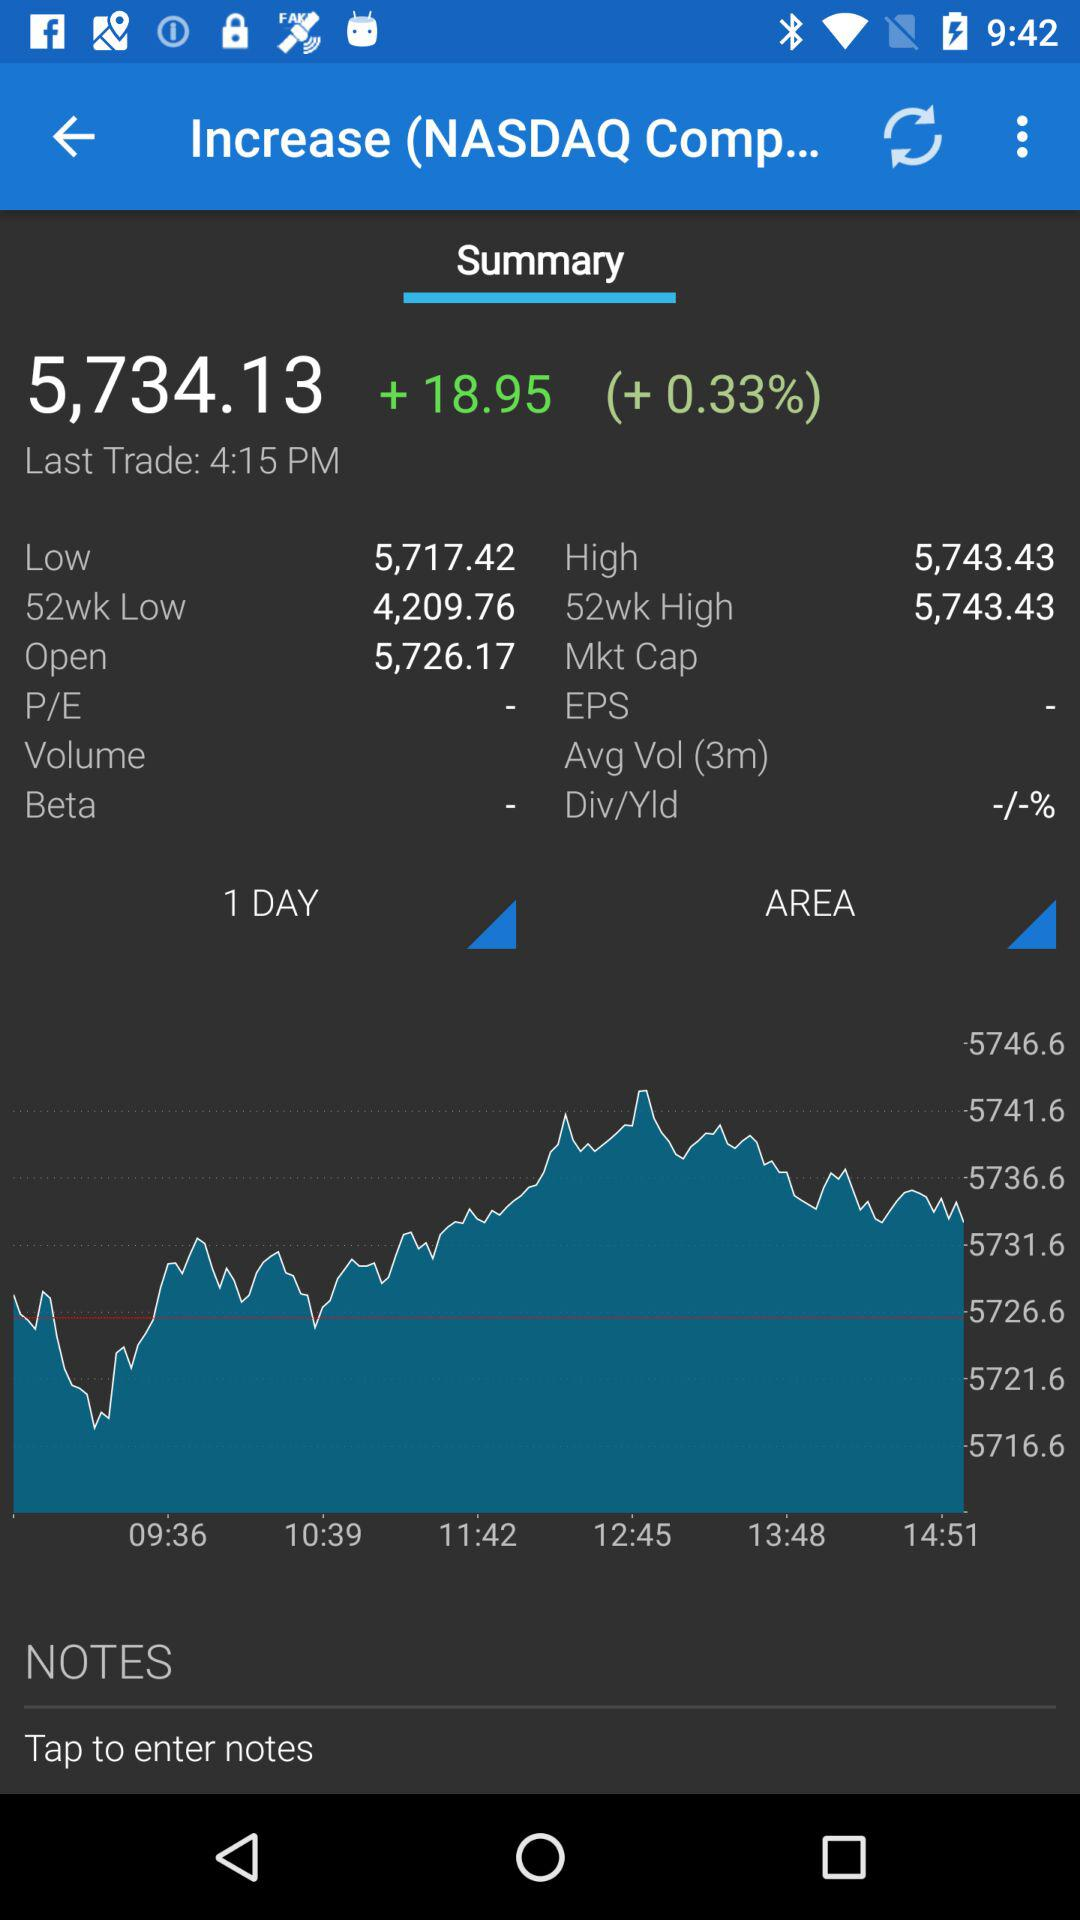When did the last trade happen? The last trade happened at 4:15 PM. 